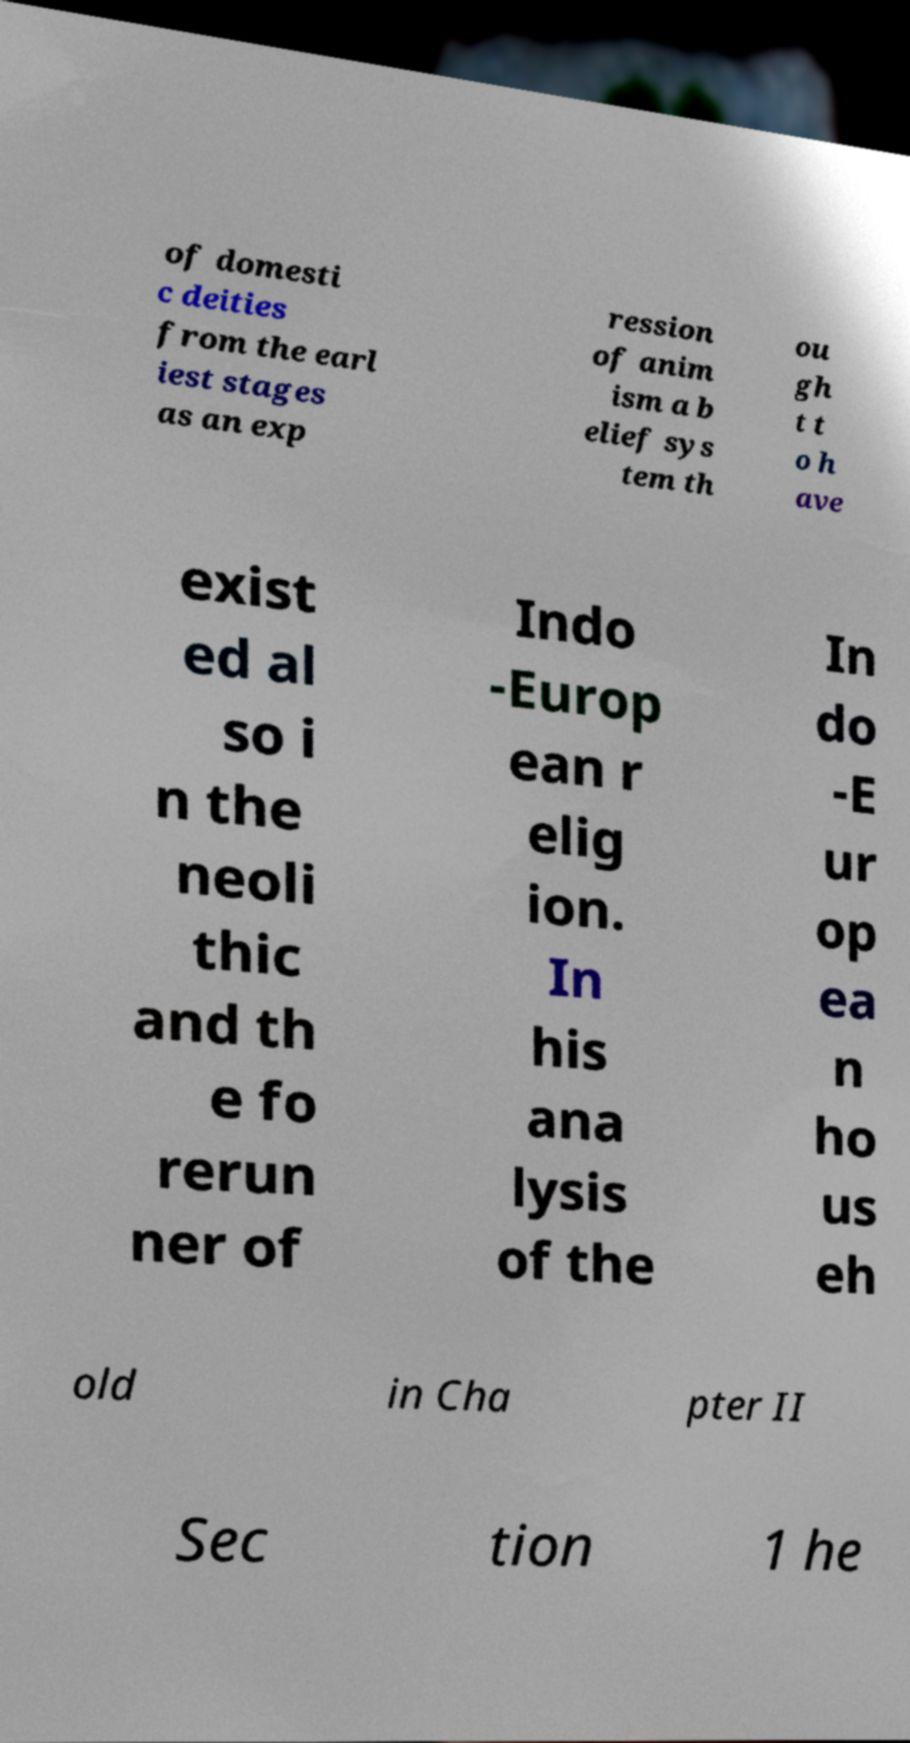Can you read and provide the text displayed in the image?This photo seems to have some interesting text. Can you extract and type it out for me? of domesti c deities from the earl iest stages as an exp ression of anim ism a b elief sys tem th ou gh t t o h ave exist ed al so i n the neoli thic and th e fo rerun ner of Indo -Europ ean r elig ion. In his ana lysis of the In do -E ur op ea n ho us eh old in Cha pter II Sec tion 1 he 